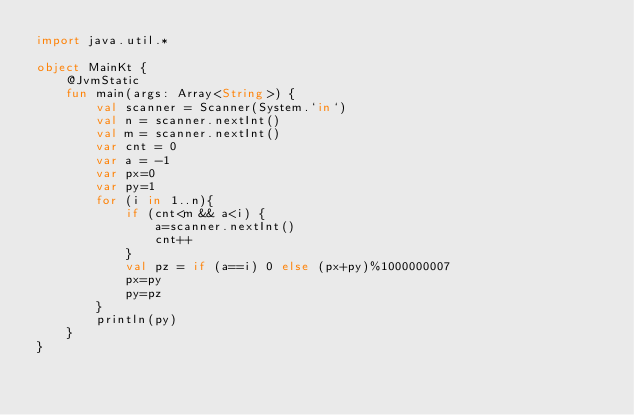<code> <loc_0><loc_0><loc_500><loc_500><_Kotlin_>import java.util.*

object MainKt {
	@JvmStatic
	fun main(args: Array<String>) {
		val scanner = Scanner(System.`in`)
		val n = scanner.nextInt()
		val m = scanner.nextInt()
		var cnt = 0
		var a = -1
		var px=0
		var py=1
		for (i in 1..n){
			if (cnt<m && a<i) {
				a=scanner.nextInt()
				cnt++
			}
			val pz = if (a==i) 0 else (px+py)%1000000007
			px=py
			py=pz
		}
		println(py)
	}
}</code> 